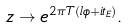<formula> <loc_0><loc_0><loc_500><loc_500>z \to e ^ { 2 \pi T ( l \phi + i t _ { E } ) } .</formula> 